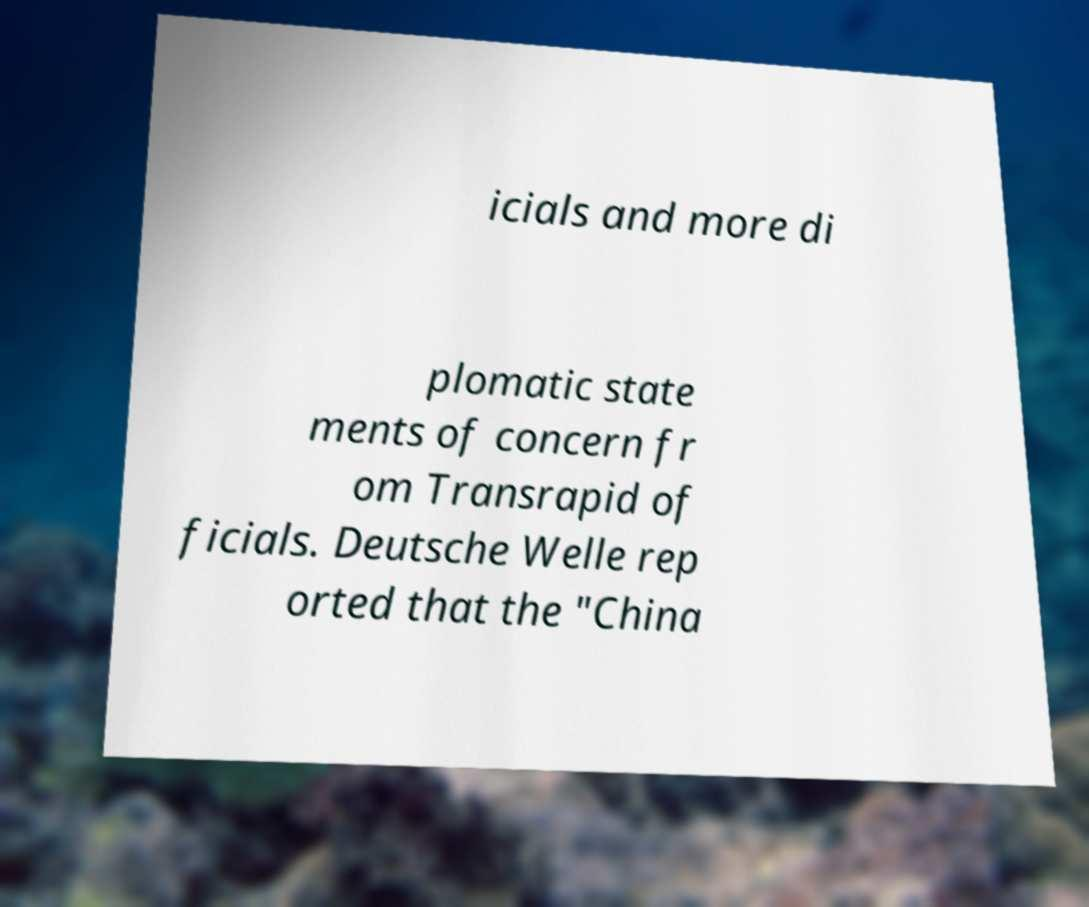For documentation purposes, I need the text within this image transcribed. Could you provide that? icials and more di plomatic state ments of concern fr om Transrapid of ficials. Deutsche Welle rep orted that the "China 